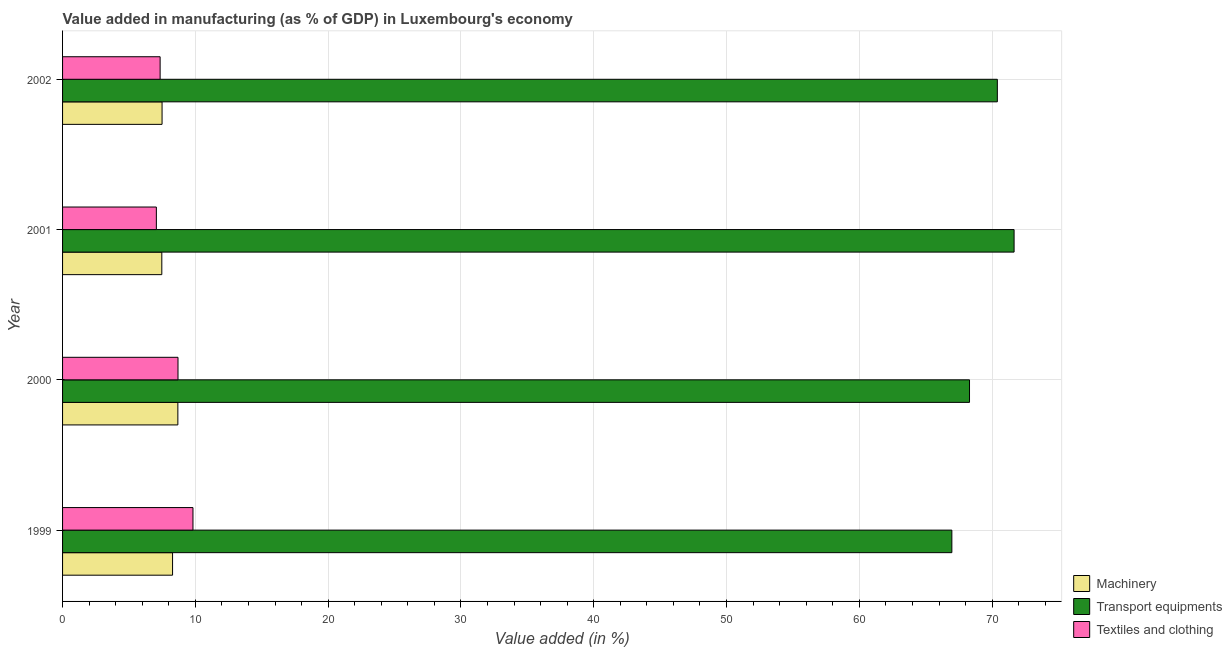How many different coloured bars are there?
Give a very brief answer. 3. Are the number of bars per tick equal to the number of legend labels?
Ensure brevity in your answer.  Yes. Are the number of bars on each tick of the Y-axis equal?
Keep it short and to the point. Yes. What is the label of the 2nd group of bars from the top?
Offer a very short reply. 2001. What is the value added in manufacturing textile and clothing in 2000?
Offer a terse response. 8.69. Across all years, what is the maximum value added in manufacturing transport equipments?
Provide a short and direct response. 71.65. Across all years, what is the minimum value added in manufacturing textile and clothing?
Your answer should be very brief. 7.06. In which year was the value added in manufacturing transport equipments maximum?
Offer a terse response. 2001. What is the total value added in manufacturing transport equipments in the graph?
Make the answer very short. 277.31. What is the difference between the value added in manufacturing textile and clothing in 2000 and that in 2002?
Make the answer very short. 1.35. What is the difference between the value added in manufacturing machinery in 2001 and the value added in manufacturing textile and clothing in 2000?
Provide a succinct answer. -1.22. What is the average value added in manufacturing textile and clothing per year?
Offer a terse response. 8.23. In the year 2002, what is the difference between the value added in manufacturing transport equipments and value added in manufacturing textile and clothing?
Keep it short and to the point. 63.05. In how many years, is the value added in manufacturing machinery greater than 52 %?
Provide a succinct answer. 0. What is the ratio of the value added in manufacturing machinery in 2000 to that in 2002?
Make the answer very short. 1.16. Is the difference between the value added in manufacturing machinery in 1999 and 2001 greater than the difference between the value added in manufacturing transport equipments in 1999 and 2001?
Give a very brief answer. Yes. What is the difference between the highest and the second highest value added in manufacturing machinery?
Ensure brevity in your answer.  0.4. What is the difference between the highest and the lowest value added in manufacturing textile and clothing?
Offer a very short reply. 2.76. In how many years, is the value added in manufacturing machinery greater than the average value added in manufacturing machinery taken over all years?
Your answer should be very brief. 2. Is the sum of the value added in manufacturing textile and clothing in 2000 and 2001 greater than the maximum value added in manufacturing machinery across all years?
Ensure brevity in your answer.  Yes. What does the 2nd bar from the top in 1999 represents?
Provide a succinct answer. Transport equipments. What does the 2nd bar from the bottom in 2001 represents?
Give a very brief answer. Transport equipments. How many bars are there?
Your answer should be very brief. 12. How many years are there in the graph?
Offer a terse response. 4. Are the values on the major ticks of X-axis written in scientific E-notation?
Provide a succinct answer. No. Does the graph contain any zero values?
Keep it short and to the point. No. Does the graph contain grids?
Ensure brevity in your answer.  Yes. How are the legend labels stacked?
Ensure brevity in your answer.  Vertical. What is the title of the graph?
Ensure brevity in your answer.  Value added in manufacturing (as % of GDP) in Luxembourg's economy. Does "Machinery" appear as one of the legend labels in the graph?
Your response must be concise. Yes. What is the label or title of the X-axis?
Offer a terse response. Value added (in %). What is the label or title of the Y-axis?
Your answer should be very brief. Year. What is the Value added (in %) of Machinery in 1999?
Offer a very short reply. 8.28. What is the Value added (in %) of Transport equipments in 1999?
Make the answer very short. 66.97. What is the Value added (in %) of Textiles and clothing in 1999?
Ensure brevity in your answer.  9.82. What is the Value added (in %) in Machinery in 2000?
Provide a succinct answer. 8.68. What is the Value added (in %) in Transport equipments in 2000?
Your response must be concise. 68.3. What is the Value added (in %) in Textiles and clothing in 2000?
Offer a very short reply. 8.69. What is the Value added (in %) of Machinery in 2001?
Your answer should be compact. 7.47. What is the Value added (in %) in Transport equipments in 2001?
Your response must be concise. 71.65. What is the Value added (in %) of Textiles and clothing in 2001?
Give a very brief answer. 7.06. What is the Value added (in %) of Machinery in 2002?
Your answer should be compact. 7.49. What is the Value added (in %) of Transport equipments in 2002?
Provide a succinct answer. 70.39. What is the Value added (in %) of Textiles and clothing in 2002?
Your answer should be very brief. 7.35. Across all years, what is the maximum Value added (in %) of Machinery?
Offer a very short reply. 8.68. Across all years, what is the maximum Value added (in %) in Transport equipments?
Make the answer very short. 71.65. Across all years, what is the maximum Value added (in %) in Textiles and clothing?
Your answer should be compact. 9.82. Across all years, what is the minimum Value added (in %) in Machinery?
Offer a very short reply. 7.47. Across all years, what is the minimum Value added (in %) of Transport equipments?
Your answer should be compact. 66.97. Across all years, what is the minimum Value added (in %) of Textiles and clothing?
Give a very brief answer. 7.06. What is the total Value added (in %) of Machinery in the graph?
Your response must be concise. 31.93. What is the total Value added (in %) in Transport equipments in the graph?
Your response must be concise. 277.31. What is the total Value added (in %) in Textiles and clothing in the graph?
Your response must be concise. 32.92. What is the difference between the Value added (in %) of Machinery in 1999 and that in 2000?
Provide a short and direct response. -0.4. What is the difference between the Value added (in %) of Transport equipments in 1999 and that in 2000?
Your response must be concise. -1.33. What is the difference between the Value added (in %) in Textiles and clothing in 1999 and that in 2000?
Your answer should be very brief. 1.13. What is the difference between the Value added (in %) of Machinery in 1999 and that in 2001?
Make the answer very short. 0.81. What is the difference between the Value added (in %) of Transport equipments in 1999 and that in 2001?
Keep it short and to the point. -4.69. What is the difference between the Value added (in %) in Textiles and clothing in 1999 and that in 2001?
Your answer should be compact. 2.76. What is the difference between the Value added (in %) in Machinery in 1999 and that in 2002?
Provide a short and direct response. 0.79. What is the difference between the Value added (in %) in Transport equipments in 1999 and that in 2002?
Ensure brevity in your answer.  -3.43. What is the difference between the Value added (in %) in Textiles and clothing in 1999 and that in 2002?
Give a very brief answer. 2.47. What is the difference between the Value added (in %) in Machinery in 2000 and that in 2001?
Provide a succinct answer. 1.21. What is the difference between the Value added (in %) of Transport equipments in 2000 and that in 2001?
Offer a very short reply. -3.36. What is the difference between the Value added (in %) in Textiles and clothing in 2000 and that in 2001?
Keep it short and to the point. 1.63. What is the difference between the Value added (in %) in Machinery in 2000 and that in 2002?
Your response must be concise. 1.19. What is the difference between the Value added (in %) in Transport equipments in 2000 and that in 2002?
Provide a succinct answer. -2.1. What is the difference between the Value added (in %) in Textiles and clothing in 2000 and that in 2002?
Provide a succinct answer. 1.35. What is the difference between the Value added (in %) of Machinery in 2001 and that in 2002?
Give a very brief answer. -0.02. What is the difference between the Value added (in %) in Transport equipments in 2001 and that in 2002?
Make the answer very short. 1.26. What is the difference between the Value added (in %) of Textiles and clothing in 2001 and that in 2002?
Offer a terse response. -0.28. What is the difference between the Value added (in %) in Machinery in 1999 and the Value added (in %) in Transport equipments in 2000?
Make the answer very short. -60.01. What is the difference between the Value added (in %) in Machinery in 1999 and the Value added (in %) in Textiles and clothing in 2000?
Give a very brief answer. -0.41. What is the difference between the Value added (in %) in Transport equipments in 1999 and the Value added (in %) in Textiles and clothing in 2000?
Provide a short and direct response. 58.27. What is the difference between the Value added (in %) of Machinery in 1999 and the Value added (in %) of Transport equipments in 2001?
Ensure brevity in your answer.  -63.37. What is the difference between the Value added (in %) in Machinery in 1999 and the Value added (in %) in Textiles and clothing in 2001?
Your answer should be very brief. 1.22. What is the difference between the Value added (in %) of Transport equipments in 1999 and the Value added (in %) of Textiles and clothing in 2001?
Offer a terse response. 59.9. What is the difference between the Value added (in %) of Machinery in 1999 and the Value added (in %) of Transport equipments in 2002?
Provide a succinct answer. -62.11. What is the difference between the Value added (in %) of Machinery in 1999 and the Value added (in %) of Textiles and clothing in 2002?
Provide a succinct answer. 0.94. What is the difference between the Value added (in %) in Transport equipments in 1999 and the Value added (in %) in Textiles and clothing in 2002?
Make the answer very short. 59.62. What is the difference between the Value added (in %) in Machinery in 2000 and the Value added (in %) in Transport equipments in 2001?
Keep it short and to the point. -62.97. What is the difference between the Value added (in %) in Machinery in 2000 and the Value added (in %) in Textiles and clothing in 2001?
Give a very brief answer. 1.62. What is the difference between the Value added (in %) of Transport equipments in 2000 and the Value added (in %) of Textiles and clothing in 2001?
Ensure brevity in your answer.  61.23. What is the difference between the Value added (in %) in Machinery in 2000 and the Value added (in %) in Transport equipments in 2002?
Offer a very short reply. -61.71. What is the difference between the Value added (in %) of Machinery in 2000 and the Value added (in %) of Textiles and clothing in 2002?
Your answer should be very brief. 1.34. What is the difference between the Value added (in %) in Transport equipments in 2000 and the Value added (in %) in Textiles and clothing in 2002?
Your answer should be very brief. 60.95. What is the difference between the Value added (in %) of Machinery in 2001 and the Value added (in %) of Transport equipments in 2002?
Keep it short and to the point. -62.92. What is the difference between the Value added (in %) of Machinery in 2001 and the Value added (in %) of Textiles and clothing in 2002?
Your response must be concise. 0.13. What is the difference between the Value added (in %) of Transport equipments in 2001 and the Value added (in %) of Textiles and clothing in 2002?
Offer a terse response. 64.31. What is the average Value added (in %) of Machinery per year?
Provide a short and direct response. 7.98. What is the average Value added (in %) in Transport equipments per year?
Your answer should be compact. 69.33. What is the average Value added (in %) of Textiles and clothing per year?
Give a very brief answer. 8.23. In the year 1999, what is the difference between the Value added (in %) of Machinery and Value added (in %) of Transport equipments?
Provide a succinct answer. -58.68. In the year 1999, what is the difference between the Value added (in %) of Machinery and Value added (in %) of Textiles and clothing?
Give a very brief answer. -1.54. In the year 1999, what is the difference between the Value added (in %) in Transport equipments and Value added (in %) in Textiles and clothing?
Provide a short and direct response. 57.15. In the year 2000, what is the difference between the Value added (in %) of Machinery and Value added (in %) of Transport equipments?
Offer a very short reply. -59.61. In the year 2000, what is the difference between the Value added (in %) in Machinery and Value added (in %) in Textiles and clothing?
Your answer should be compact. -0.01. In the year 2000, what is the difference between the Value added (in %) in Transport equipments and Value added (in %) in Textiles and clothing?
Your response must be concise. 59.6. In the year 2001, what is the difference between the Value added (in %) in Machinery and Value added (in %) in Transport equipments?
Provide a succinct answer. -64.18. In the year 2001, what is the difference between the Value added (in %) in Machinery and Value added (in %) in Textiles and clothing?
Your answer should be compact. 0.41. In the year 2001, what is the difference between the Value added (in %) of Transport equipments and Value added (in %) of Textiles and clothing?
Provide a succinct answer. 64.59. In the year 2002, what is the difference between the Value added (in %) of Machinery and Value added (in %) of Transport equipments?
Your answer should be compact. -62.9. In the year 2002, what is the difference between the Value added (in %) of Machinery and Value added (in %) of Textiles and clothing?
Ensure brevity in your answer.  0.15. In the year 2002, what is the difference between the Value added (in %) of Transport equipments and Value added (in %) of Textiles and clothing?
Give a very brief answer. 63.05. What is the ratio of the Value added (in %) of Machinery in 1999 to that in 2000?
Your response must be concise. 0.95. What is the ratio of the Value added (in %) in Transport equipments in 1999 to that in 2000?
Keep it short and to the point. 0.98. What is the ratio of the Value added (in %) in Textiles and clothing in 1999 to that in 2000?
Offer a terse response. 1.13. What is the ratio of the Value added (in %) in Machinery in 1999 to that in 2001?
Your answer should be very brief. 1.11. What is the ratio of the Value added (in %) in Transport equipments in 1999 to that in 2001?
Ensure brevity in your answer.  0.93. What is the ratio of the Value added (in %) of Textiles and clothing in 1999 to that in 2001?
Provide a succinct answer. 1.39. What is the ratio of the Value added (in %) in Machinery in 1999 to that in 2002?
Offer a terse response. 1.11. What is the ratio of the Value added (in %) of Transport equipments in 1999 to that in 2002?
Your answer should be compact. 0.95. What is the ratio of the Value added (in %) of Textiles and clothing in 1999 to that in 2002?
Offer a very short reply. 1.34. What is the ratio of the Value added (in %) in Machinery in 2000 to that in 2001?
Offer a terse response. 1.16. What is the ratio of the Value added (in %) in Transport equipments in 2000 to that in 2001?
Provide a short and direct response. 0.95. What is the ratio of the Value added (in %) of Textiles and clothing in 2000 to that in 2001?
Provide a short and direct response. 1.23. What is the ratio of the Value added (in %) in Machinery in 2000 to that in 2002?
Your answer should be compact. 1.16. What is the ratio of the Value added (in %) in Transport equipments in 2000 to that in 2002?
Ensure brevity in your answer.  0.97. What is the ratio of the Value added (in %) in Textiles and clothing in 2000 to that in 2002?
Keep it short and to the point. 1.18. What is the ratio of the Value added (in %) of Machinery in 2001 to that in 2002?
Offer a terse response. 1. What is the ratio of the Value added (in %) of Transport equipments in 2001 to that in 2002?
Offer a terse response. 1.02. What is the ratio of the Value added (in %) in Textiles and clothing in 2001 to that in 2002?
Ensure brevity in your answer.  0.96. What is the difference between the highest and the second highest Value added (in %) in Machinery?
Your answer should be very brief. 0.4. What is the difference between the highest and the second highest Value added (in %) of Transport equipments?
Give a very brief answer. 1.26. What is the difference between the highest and the second highest Value added (in %) of Textiles and clothing?
Keep it short and to the point. 1.13. What is the difference between the highest and the lowest Value added (in %) of Machinery?
Make the answer very short. 1.21. What is the difference between the highest and the lowest Value added (in %) of Transport equipments?
Offer a very short reply. 4.69. What is the difference between the highest and the lowest Value added (in %) of Textiles and clothing?
Your response must be concise. 2.76. 